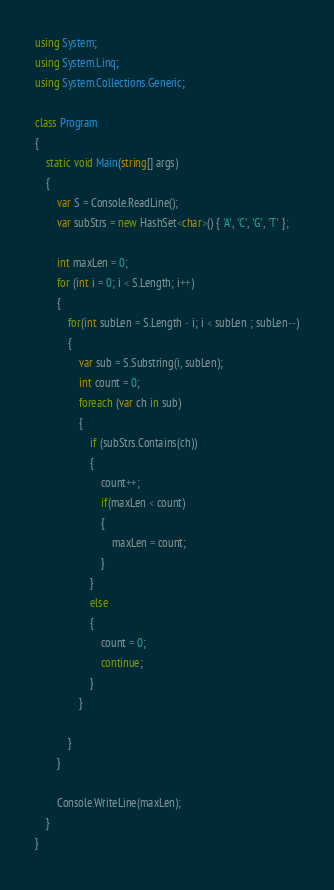Convert code to text. <code><loc_0><loc_0><loc_500><loc_500><_C#_>using System;
using System.Linq;
using System.Collections.Generic;

class Program
{
    static void Main(string[] args)
    {
        var S = Console.ReadLine();
        var subStrs = new HashSet<char>() { 'A', 'C', 'G', 'T' };

        int maxLen = 0;
        for (int i = 0; i < S.Length; i++)
        {
            for(int subLen = S.Length - i; i < subLen ; subLen--)
            {
                var sub = S.Substring(i, subLen);
                int count = 0;
                foreach (var ch in sub)
                {
                    if (subStrs.Contains(ch))
                    {
                        count++;
                        if(maxLen < count)
                        {
                            maxLen = count;
                        }
                    }
                    else
                    {
                        count = 0;
                        continue;
                    }
                }

            }
        }

        Console.WriteLine(maxLen);
    }
}

</code> 